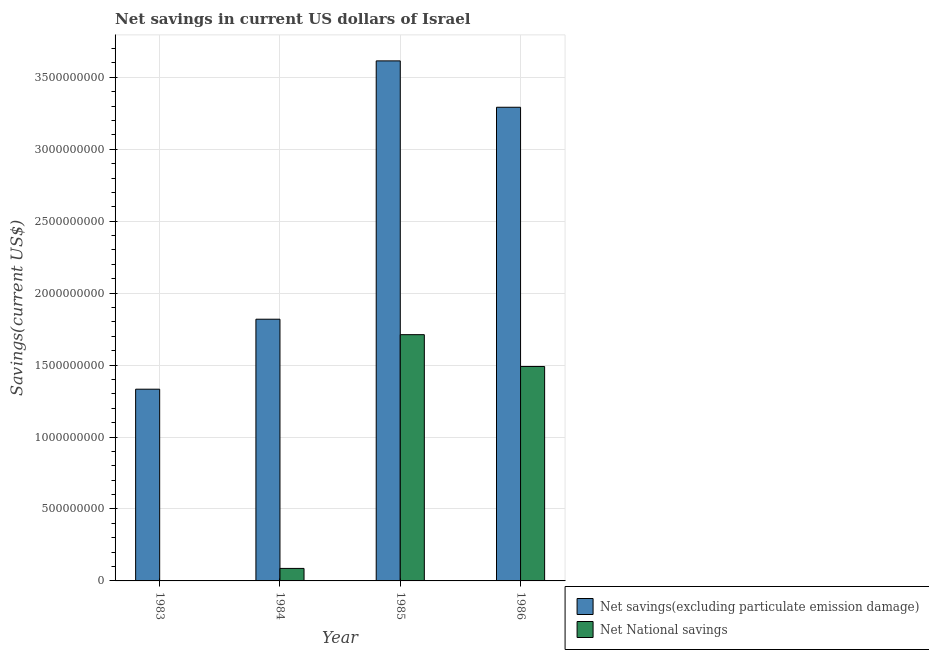Are the number of bars on each tick of the X-axis equal?
Your answer should be very brief. No. What is the net savings(excluding particulate emission damage) in 1985?
Offer a terse response. 3.61e+09. Across all years, what is the maximum net national savings?
Ensure brevity in your answer.  1.71e+09. In which year was the net national savings maximum?
Offer a terse response. 1985. What is the total net national savings in the graph?
Make the answer very short. 3.29e+09. What is the difference between the net savings(excluding particulate emission damage) in 1983 and that in 1985?
Your answer should be compact. -2.28e+09. What is the difference between the net national savings in 1984 and the net savings(excluding particulate emission damage) in 1986?
Your answer should be very brief. -1.40e+09. What is the average net national savings per year?
Offer a very short reply. 8.22e+08. What is the ratio of the net national savings in 1984 to that in 1986?
Give a very brief answer. 0.06. Is the net national savings in 1984 less than that in 1985?
Your answer should be very brief. Yes. Is the difference between the net savings(excluding particulate emission damage) in 1984 and 1986 greater than the difference between the net national savings in 1984 and 1986?
Your answer should be compact. No. What is the difference between the highest and the second highest net national savings?
Make the answer very short. 2.21e+08. What is the difference between the highest and the lowest net national savings?
Give a very brief answer. 1.71e+09. Is the sum of the net national savings in 1984 and 1986 greater than the maximum net savings(excluding particulate emission damage) across all years?
Your answer should be compact. No. How many bars are there?
Offer a very short reply. 7. Are all the bars in the graph horizontal?
Offer a very short reply. No. How many years are there in the graph?
Your answer should be compact. 4. What is the difference between two consecutive major ticks on the Y-axis?
Make the answer very short. 5.00e+08. Does the graph contain any zero values?
Ensure brevity in your answer.  Yes. What is the title of the graph?
Your answer should be very brief. Net savings in current US dollars of Israel. What is the label or title of the X-axis?
Your answer should be very brief. Year. What is the label or title of the Y-axis?
Offer a terse response. Savings(current US$). What is the Savings(current US$) of Net savings(excluding particulate emission damage) in 1983?
Offer a very short reply. 1.33e+09. What is the Savings(current US$) of Net National savings in 1983?
Offer a very short reply. 0. What is the Savings(current US$) in Net savings(excluding particulate emission damage) in 1984?
Offer a terse response. 1.82e+09. What is the Savings(current US$) in Net National savings in 1984?
Your answer should be very brief. 8.69e+07. What is the Savings(current US$) of Net savings(excluding particulate emission damage) in 1985?
Provide a short and direct response. 3.61e+09. What is the Savings(current US$) of Net National savings in 1985?
Offer a very short reply. 1.71e+09. What is the Savings(current US$) of Net savings(excluding particulate emission damage) in 1986?
Offer a very short reply. 3.29e+09. What is the Savings(current US$) of Net National savings in 1986?
Offer a very short reply. 1.49e+09. Across all years, what is the maximum Savings(current US$) of Net savings(excluding particulate emission damage)?
Provide a short and direct response. 3.61e+09. Across all years, what is the maximum Savings(current US$) of Net National savings?
Your answer should be very brief. 1.71e+09. Across all years, what is the minimum Savings(current US$) in Net savings(excluding particulate emission damage)?
Ensure brevity in your answer.  1.33e+09. Across all years, what is the minimum Savings(current US$) in Net National savings?
Give a very brief answer. 0. What is the total Savings(current US$) in Net savings(excluding particulate emission damage) in the graph?
Provide a short and direct response. 1.01e+1. What is the total Savings(current US$) in Net National savings in the graph?
Make the answer very short. 3.29e+09. What is the difference between the Savings(current US$) of Net savings(excluding particulate emission damage) in 1983 and that in 1984?
Provide a short and direct response. -4.86e+08. What is the difference between the Savings(current US$) in Net savings(excluding particulate emission damage) in 1983 and that in 1985?
Your response must be concise. -2.28e+09. What is the difference between the Savings(current US$) of Net savings(excluding particulate emission damage) in 1983 and that in 1986?
Provide a succinct answer. -1.96e+09. What is the difference between the Savings(current US$) of Net savings(excluding particulate emission damage) in 1984 and that in 1985?
Your answer should be very brief. -1.80e+09. What is the difference between the Savings(current US$) of Net National savings in 1984 and that in 1985?
Your response must be concise. -1.62e+09. What is the difference between the Savings(current US$) of Net savings(excluding particulate emission damage) in 1984 and that in 1986?
Keep it short and to the point. -1.47e+09. What is the difference between the Savings(current US$) of Net National savings in 1984 and that in 1986?
Provide a short and direct response. -1.40e+09. What is the difference between the Savings(current US$) of Net savings(excluding particulate emission damage) in 1985 and that in 1986?
Your answer should be compact. 3.22e+08. What is the difference between the Savings(current US$) in Net National savings in 1985 and that in 1986?
Offer a terse response. 2.21e+08. What is the difference between the Savings(current US$) in Net savings(excluding particulate emission damage) in 1983 and the Savings(current US$) in Net National savings in 1984?
Provide a short and direct response. 1.25e+09. What is the difference between the Savings(current US$) in Net savings(excluding particulate emission damage) in 1983 and the Savings(current US$) in Net National savings in 1985?
Ensure brevity in your answer.  -3.79e+08. What is the difference between the Savings(current US$) in Net savings(excluding particulate emission damage) in 1983 and the Savings(current US$) in Net National savings in 1986?
Give a very brief answer. -1.58e+08. What is the difference between the Savings(current US$) of Net savings(excluding particulate emission damage) in 1984 and the Savings(current US$) of Net National savings in 1985?
Make the answer very short. 1.07e+08. What is the difference between the Savings(current US$) of Net savings(excluding particulate emission damage) in 1984 and the Savings(current US$) of Net National savings in 1986?
Keep it short and to the point. 3.29e+08. What is the difference between the Savings(current US$) of Net savings(excluding particulate emission damage) in 1985 and the Savings(current US$) of Net National savings in 1986?
Keep it short and to the point. 2.12e+09. What is the average Savings(current US$) of Net savings(excluding particulate emission damage) per year?
Your answer should be very brief. 2.51e+09. What is the average Savings(current US$) of Net National savings per year?
Your response must be concise. 8.22e+08. In the year 1984, what is the difference between the Savings(current US$) in Net savings(excluding particulate emission damage) and Savings(current US$) in Net National savings?
Your answer should be compact. 1.73e+09. In the year 1985, what is the difference between the Savings(current US$) of Net savings(excluding particulate emission damage) and Savings(current US$) of Net National savings?
Your answer should be compact. 1.90e+09. In the year 1986, what is the difference between the Savings(current US$) in Net savings(excluding particulate emission damage) and Savings(current US$) in Net National savings?
Your answer should be very brief. 1.80e+09. What is the ratio of the Savings(current US$) in Net savings(excluding particulate emission damage) in 1983 to that in 1984?
Ensure brevity in your answer.  0.73. What is the ratio of the Savings(current US$) in Net savings(excluding particulate emission damage) in 1983 to that in 1985?
Offer a terse response. 0.37. What is the ratio of the Savings(current US$) in Net savings(excluding particulate emission damage) in 1983 to that in 1986?
Provide a succinct answer. 0.4. What is the ratio of the Savings(current US$) in Net savings(excluding particulate emission damage) in 1984 to that in 1985?
Offer a terse response. 0.5. What is the ratio of the Savings(current US$) in Net National savings in 1984 to that in 1985?
Provide a short and direct response. 0.05. What is the ratio of the Savings(current US$) in Net savings(excluding particulate emission damage) in 1984 to that in 1986?
Keep it short and to the point. 0.55. What is the ratio of the Savings(current US$) in Net National savings in 1984 to that in 1986?
Your response must be concise. 0.06. What is the ratio of the Savings(current US$) in Net savings(excluding particulate emission damage) in 1985 to that in 1986?
Your response must be concise. 1.1. What is the ratio of the Savings(current US$) of Net National savings in 1985 to that in 1986?
Provide a succinct answer. 1.15. What is the difference between the highest and the second highest Savings(current US$) of Net savings(excluding particulate emission damage)?
Ensure brevity in your answer.  3.22e+08. What is the difference between the highest and the second highest Savings(current US$) in Net National savings?
Offer a terse response. 2.21e+08. What is the difference between the highest and the lowest Savings(current US$) in Net savings(excluding particulate emission damage)?
Offer a terse response. 2.28e+09. What is the difference between the highest and the lowest Savings(current US$) in Net National savings?
Offer a very short reply. 1.71e+09. 